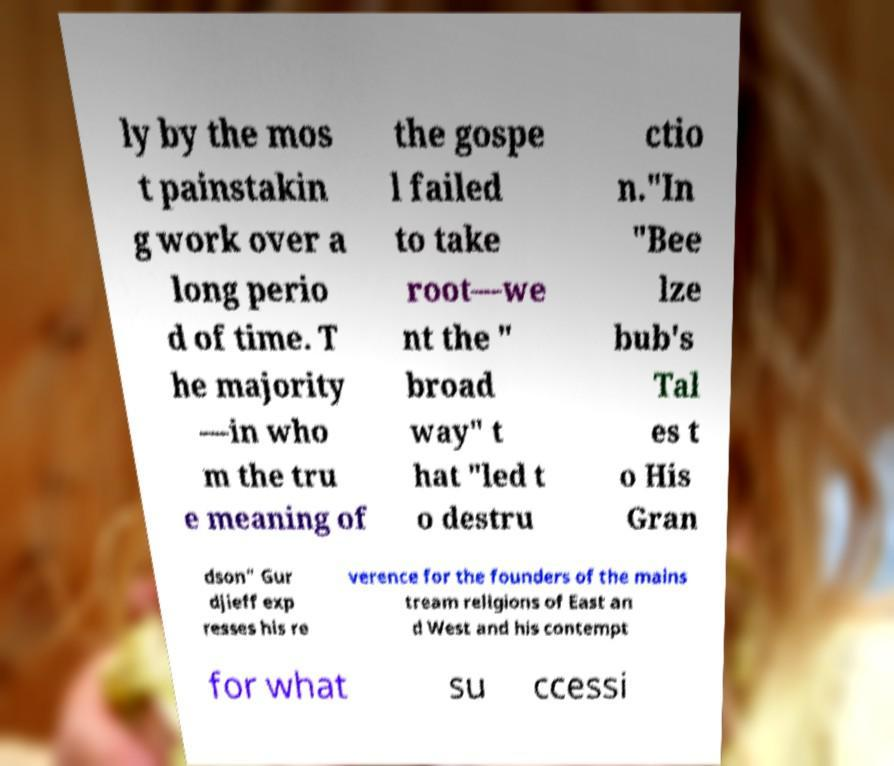Could you assist in decoding the text presented in this image and type it out clearly? ly by the mos t painstakin g work over a long perio d of time. T he majority —in who m the tru e meaning of the gospe l failed to take root—we nt the " broad way" t hat "led t o destru ctio n."In "Bee lze bub's Tal es t o His Gran dson" Gur djieff exp resses his re verence for the founders of the mains tream religions of East an d West and his contempt for what su ccessi 